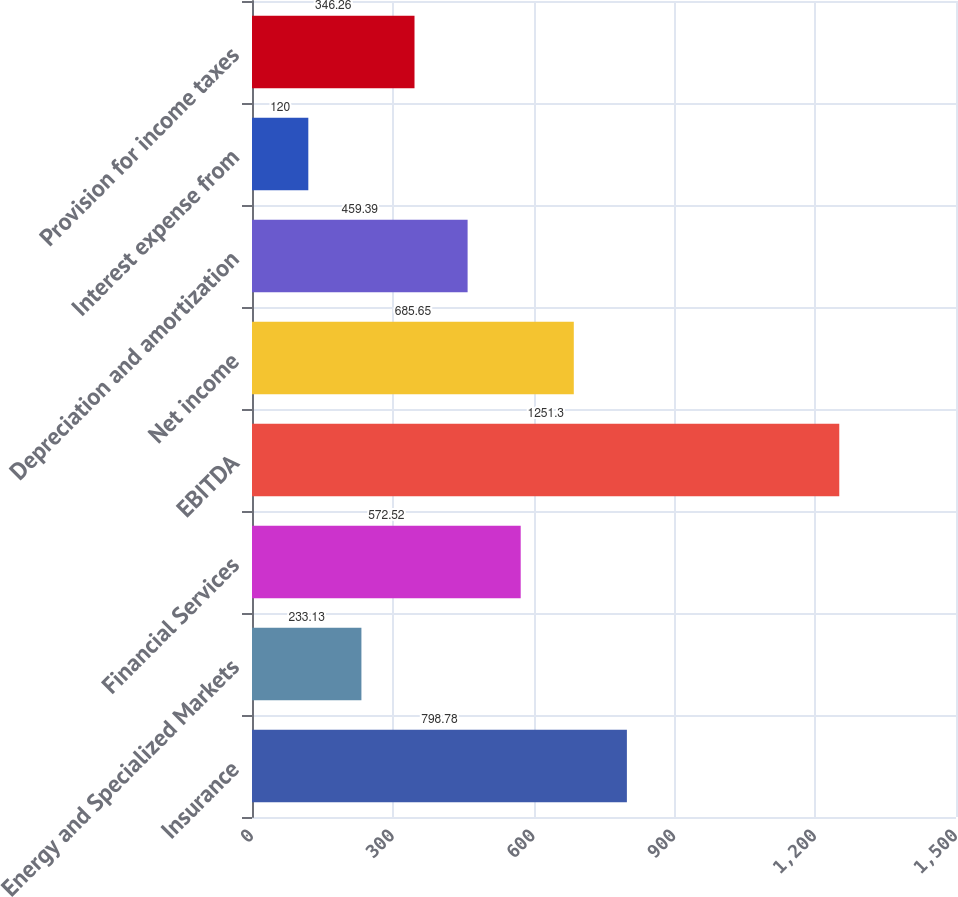Convert chart. <chart><loc_0><loc_0><loc_500><loc_500><bar_chart><fcel>Insurance<fcel>Energy and Specialized Markets<fcel>Financial Services<fcel>EBITDA<fcel>Net income<fcel>Depreciation and amortization<fcel>Interest expense from<fcel>Provision for income taxes<nl><fcel>798.78<fcel>233.13<fcel>572.52<fcel>1251.3<fcel>685.65<fcel>459.39<fcel>120<fcel>346.26<nl></chart> 